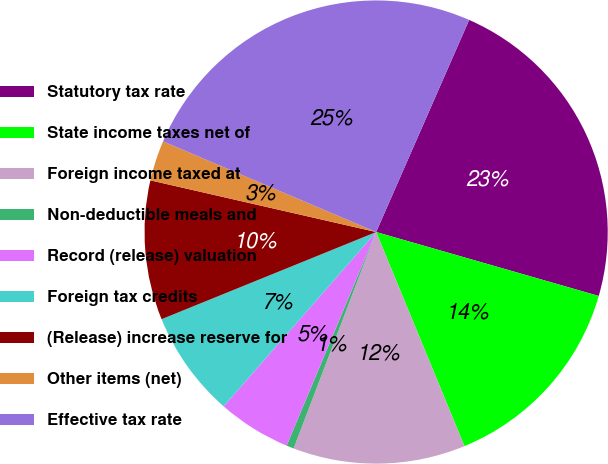Convert chart. <chart><loc_0><loc_0><loc_500><loc_500><pie_chart><fcel>Statutory tax rate<fcel>State income taxes net of<fcel>Foreign income taxed at<fcel>Non-deductible meals and<fcel>Record (release) valuation<fcel>Foreign tax credits<fcel>(Release) increase reserve for<fcel>Other items (net)<fcel>Effective tax rate<nl><fcel>22.87%<fcel>14.32%<fcel>12.02%<fcel>0.52%<fcel>5.12%<fcel>7.42%<fcel>9.72%<fcel>2.82%<fcel>25.17%<nl></chart> 